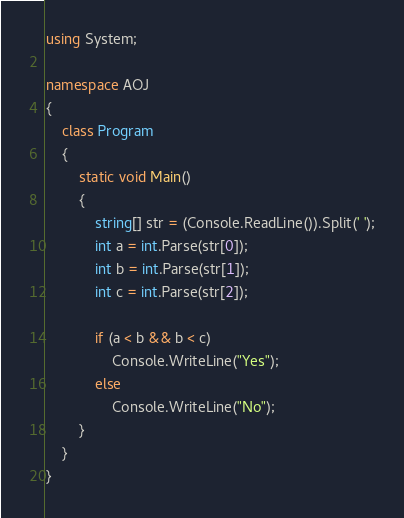Convert code to text. <code><loc_0><loc_0><loc_500><loc_500><_C#_>using System;

namespace AOJ
{
    class Program
    {
        static void Main()
        {
            string[] str = (Console.ReadLine()).Split(' ');
            int a = int.Parse(str[0]);
            int b = int.Parse(str[1]);
            int c = int.Parse(str[2]);

            if (a < b && b < c)
                Console.WriteLine("Yes");
            else
                Console.WriteLine("No");
        }
    }
}</code> 